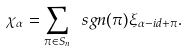<formula> <loc_0><loc_0><loc_500><loc_500>\chi _ { \alpha } = \sum _ { \pi \in S _ { n } } \ s g n ( \pi ) \xi _ { \alpha - i d + \pi } .</formula> 